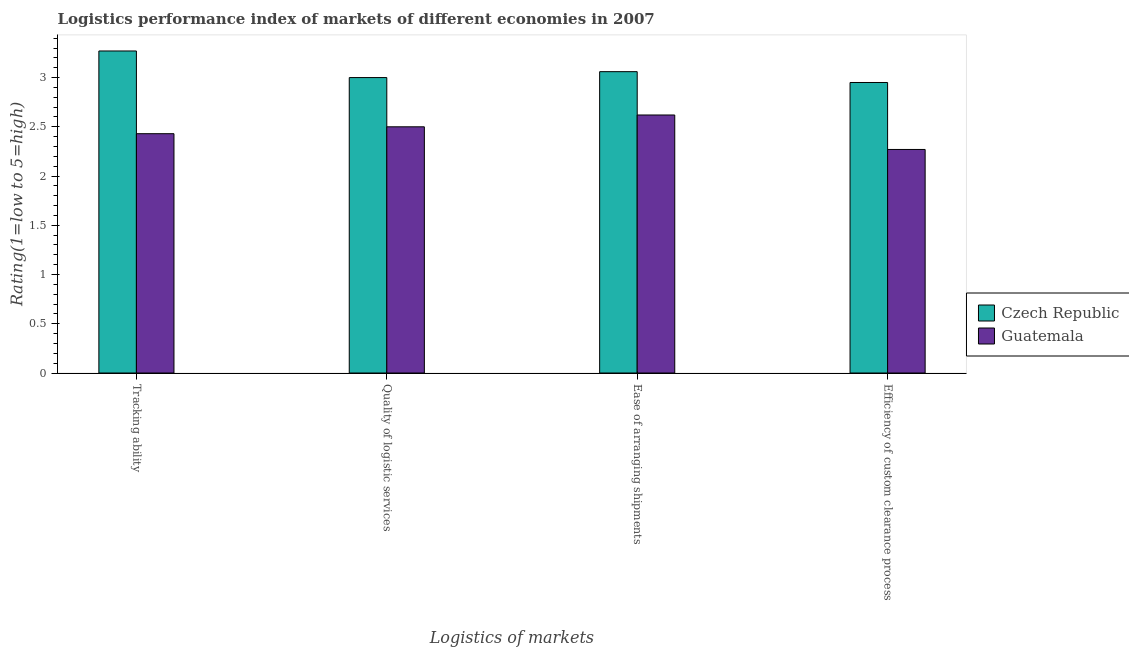How many groups of bars are there?
Ensure brevity in your answer.  4. What is the label of the 4th group of bars from the left?
Make the answer very short. Efficiency of custom clearance process. What is the lpi rating of tracking ability in Czech Republic?
Offer a terse response. 3.27. Across all countries, what is the maximum lpi rating of quality of logistic services?
Give a very brief answer. 3. Across all countries, what is the minimum lpi rating of ease of arranging shipments?
Offer a very short reply. 2.62. In which country was the lpi rating of tracking ability maximum?
Provide a succinct answer. Czech Republic. In which country was the lpi rating of ease of arranging shipments minimum?
Provide a succinct answer. Guatemala. What is the total lpi rating of efficiency of custom clearance process in the graph?
Make the answer very short. 5.22. What is the difference between the lpi rating of efficiency of custom clearance process in Guatemala and that in Czech Republic?
Your response must be concise. -0.68. What is the difference between the lpi rating of efficiency of custom clearance process in Czech Republic and the lpi rating of quality of logistic services in Guatemala?
Your response must be concise. 0.45. What is the average lpi rating of quality of logistic services per country?
Provide a succinct answer. 2.75. What is the difference between the lpi rating of efficiency of custom clearance process and lpi rating of quality of logistic services in Guatemala?
Your answer should be very brief. -0.23. What is the ratio of the lpi rating of ease of arranging shipments in Guatemala to that in Czech Republic?
Make the answer very short. 0.86. Is the lpi rating of ease of arranging shipments in Czech Republic less than that in Guatemala?
Provide a succinct answer. No. Is the difference between the lpi rating of ease of arranging shipments in Czech Republic and Guatemala greater than the difference between the lpi rating of tracking ability in Czech Republic and Guatemala?
Your response must be concise. No. What is the difference between the highest and the second highest lpi rating of efficiency of custom clearance process?
Ensure brevity in your answer.  0.68. What is the difference between the highest and the lowest lpi rating of tracking ability?
Your response must be concise. 0.84. Is the sum of the lpi rating of efficiency of custom clearance process in Czech Republic and Guatemala greater than the maximum lpi rating of tracking ability across all countries?
Your answer should be very brief. Yes. What does the 2nd bar from the left in Efficiency of custom clearance process represents?
Provide a succinct answer. Guatemala. What does the 1st bar from the right in Tracking ability represents?
Make the answer very short. Guatemala. Is it the case that in every country, the sum of the lpi rating of tracking ability and lpi rating of quality of logistic services is greater than the lpi rating of ease of arranging shipments?
Provide a short and direct response. Yes. How many bars are there?
Your answer should be compact. 8. Are all the bars in the graph horizontal?
Keep it short and to the point. No. How many countries are there in the graph?
Give a very brief answer. 2. Does the graph contain any zero values?
Your answer should be compact. No. Does the graph contain grids?
Your answer should be very brief. No. How many legend labels are there?
Your answer should be very brief. 2. What is the title of the graph?
Provide a short and direct response. Logistics performance index of markets of different economies in 2007. Does "Micronesia" appear as one of the legend labels in the graph?
Ensure brevity in your answer.  No. What is the label or title of the X-axis?
Provide a short and direct response. Logistics of markets. What is the label or title of the Y-axis?
Offer a very short reply. Rating(1=low to 5=high). What is the Rating(1=low to 5=high) of Czech Republic in Tracking ability?
Provide a succinct answer. 3.27. What is the Rating(1=low to 5=high) in Guatemala in Tracking ability?
Provide a short and direct response. 2.43. What is the Rating(1=low to 5=high) in Czech Republic in Ease of arranging shipments?
Provide a succinct answer. 3.06. What is the Rating(1=low to 5=high) of Guatemala in Ease of arranging shipments?
Make the answer very short. 2.62. What is the Rating(1=low to 5=high) in Czech Republic in Efficiency of custom clearance process?
Your answer should be very brief. 2.95. What is the Rating(1=low to 5=high) of Guatemala in Efficiency of custom clearance process?
Provide a succinct answer. 2.27. Across all Logistics of markets, what is the maximum Rating(1=low to 5=high) of Czech Republic?
Ensure brevity in your answer.  3.27. Across all Logistics of markets, what is the maximum Rating(1=low to 5=high) of Guatemala?
Make the answer very short. 2.62. Across all Logistics of markets, what is the minimum Rating(1=low to 5=high) in Czech Republic?
Make the answer very short. 2.95. Across all Logistics of markets, what is the minimum Rating(1=low to 5=high) of Guatemala?
Make the answer very short. 2.27. What is the total Rating(1=low to 5=high) of Czech Republic in the graph?
Offer a terse response. 12.28. What is the total Rating(1=low to 5=high) of Guatemala in the graph?
Your response must be concise. 9.82. What is the difference between the Rating(1=low to 5=high) of Czech Republic in Tracking ability and that in Quality of logistic services?
Keep it short and to the point. 0.27. What is the difference between the Rating(1=low to 5=high) in Guatemala in Tracking ability and that in Quality of logistic services?
Your answer should be very brief. -0.07. What is the difference between the Rating(1=low to 5=high) in Czech Republic in Tracking ability and that in Ease of arranging shipments?
Offer a very short reply. 0.21. What is the difference between the Rating(1=low to 5=high) of Guatemala in Tracking ability and that in Ease of arranging shipments?
Offer a terse response. -0.19. What is the difference between the Rating(1=low to 5=high) of Czech Republic in Tracking ability and that in Efficiency of custom clearance process?
Offer a terse response. 0.32. What is the difference between the Rating(1=low to 5=high) of Guatemala in Tracking ability and that in Efficiency of custom clearance process?
Offer a very short reply. 0.16. What is the difference between the Rating(1=low to 5=high) in Czech Republic in Quality of logistic services and that in Ease of arranging shipments?
Provide a short and direct response. -0.06. What is the difference between the Rating(1=low to 5=high) of Guatemala in Quality of logistic services and that in Ease of arranging shipments?
Your answer should be compact. -0.12. What is the difference between the Rating(1=low to 5=high) of Czech Republic in Quality of logistic services and that in Efficiency of custom clearance process?
Provide a succinct answer. 0.05. What is the difference between the Rating(1=low to 5=high) of Guatemala in Quality of logistic services and that in Efficiency of custom clearance process?
Offer a terse response. 0.23. What is the difference between the Rating(1=low to 5=high) in Czech Republic in Ease of arranging shipments and that in Efficiency of custom clearance process?
Provide a succinct answer. 0.11. What is the difference between the Rating(1=low to 5=high) of Guatemala in Ease of arranging shipments and that in Efficiency of custom clearance process?
Offer a terse response. 0.35. What is the difference between the Rating(1=low to 5=high) of Czech Republic in Tracking ability and the Rating(1=low to 5=high) of Guatemala in Quality of logistic services?
Make the answer very short. 0.77. What is the difference between the Rating(1=low to 5=high) in Czech Republic in Tracking ability and the Rating(1=low to 5=high) in Guatemala in Ease of arranging shipments?
Ensure brevity in your answer.  0.65. What is the difference between the Rating(1=low to 5=high) in Czech Republic in Tracking ability and the Rating(1=low to 5=high) in Guatemala in Efficiency of custom clearance process?
Your answer should be compact. 1. What is the difference between the Rating(1=low to 5=high) of Czech Republic in Quality of logistic services and the Rating(1=low to 5=high) of Guatemala in Ease of arranging shipments?
Offer a terse response. 0.38. What is the difference between the Rating(1=low to 5=high) in Czech Republic in Quality of logistic services and the Rating(1=low to 5=high) in Guatemala in Efficiency of custom clearance process?
Give a very brief answer. 0.73. What is the difference between the Rating(1=low to 5=high) in Czech Republic in Ease of arranging shipments and the Rating(1=low to 5=high) in Guatemala in Efficiency of custom clearance process?
Provide a short and direct response. 0.79. What is the average Rating(1=low to 5=high) in Czech Republic per Logistics of markets?
Make the answer very short. 3.07. What is the average Rating(1=low to 5=high) in Guatemala per Logistics of markets?
Provide a short and direct response. 2.46. What is the difference between the Rating(1=low to 5=high) in Czech Republic and Rating(1=low to 5=high) in Guatemala in Tracking ability?
Your answer should be very brief. 0.84. What is the difference between the Rating(1=low to 5=high) in Czech Republic and Rating(1=low to 5=high) in Guatemala in Ease of arranging shipments?
Make the answer very short. 0.44. What is the difference between the Rating(1=low to 5=high) of Czech Republic and Rating(1=low to 5=high) of Guatemala in Efficiency of custom clearance process?
Keep it short and to the point. 0.68. What is the ratio of the Rating(1=low to 5=high) of Czech Republic in Tracking ability to that in Quality of logistic services?
Offer a very short reply. 1.09. What is the ratio of the Rating(1=low to 5=high) of Guatemala in Tracking ability to that in Quality of logistic services?
Make the answer very short. 0.97. What is the ratio of the Rating(1=low to 5=high) in Czech Republic in Tracking ability to that in Ease of arranging shipments?
Your response must be concise. 1.07. What is the ratio of the Rating(1=low to 5=high) of Guatemala in Tracking ability to that in Ease of arranging shipments?
Give a very brief answer. 0.93. What is the ratio of the Rating(1=low to 5=high) in Czech Republic in Tracking ability to that in Efficiency of custom clearance process?
Make the answer very short. 1.11. What is the ratio of the Rating(1=low to 5=high) in Guatemala in Tracking ability to that in Efficiency of custom clearance process?
Your answer should be compact. 1.07. What is the ratio of the Rating(1=low to 5=high) in Czech Republic in Quality of logistic services to that in Ease of arranging shipments?
Make the answer very short. 0.98. What is the ratio of the Rating(1=low to 5=high) in Guatemala in Quality of logistic services to that in Ease of arranging shipments?
Give a very brief answer. 0.95. What is the ratio of the Rating(1=low to 5=high) in Czech Republic in Quality of logistic services to that in Efficiency of custom clearance process?
Offer a very short reply. 1.02. What is the ratio of the Rating(1=low to 5=high) of Guatemala in Quality of logistic services to that in Efficiency of custom clearance process?
Provide a short and direct response. 1.1. What is the ratio of the Rating(1=low to 5=high) of Czech Republic in Ease of arranging shipments to that in Efficiency of custom clearance process?
Ensure brevity in your answer.  1.04. What is the ratio of the Rating(1=low to 5=high) in Guatemala in Ease of arranging shipments to that in Efficiency of custom clearance process?
Make the answer very short. 1.15. What is the difference between the highest and the second highest Rating(1=low to 5=high) of Czech Republic?
Offer a very short reply. 0.21. What is the difference between the highest and the second highest Rating(1=low to 5=high) in Guatemala?
Keep it short and to the point. 0.12. What is the difference between the highest and the lowest Rating(1=low to 5=high) of Czech Republic?
Provide a short and direct response. 0.32. What is the difference between the highest and the lowest Rating(1=low to 5=high) in Guatemala?
Provide a short and direct response. 0.35. 